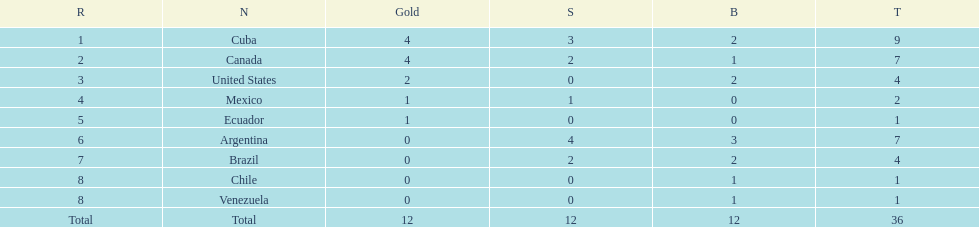What is the total number of nations that did not win gold? 4. 